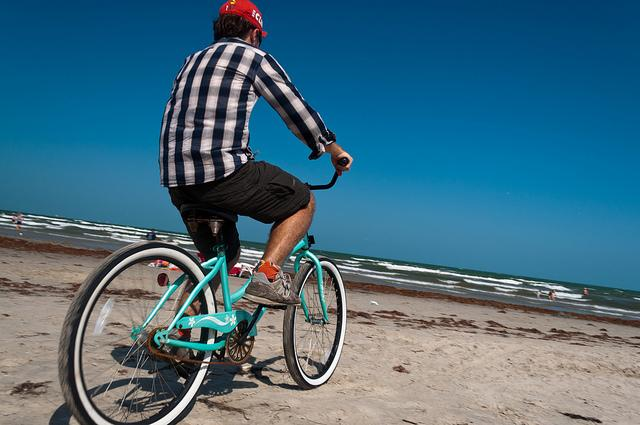What will happen to this mans feet if he doesn't stop?

Choices:
A) nothing
B) get wet
C) twist
D) burn get wet 